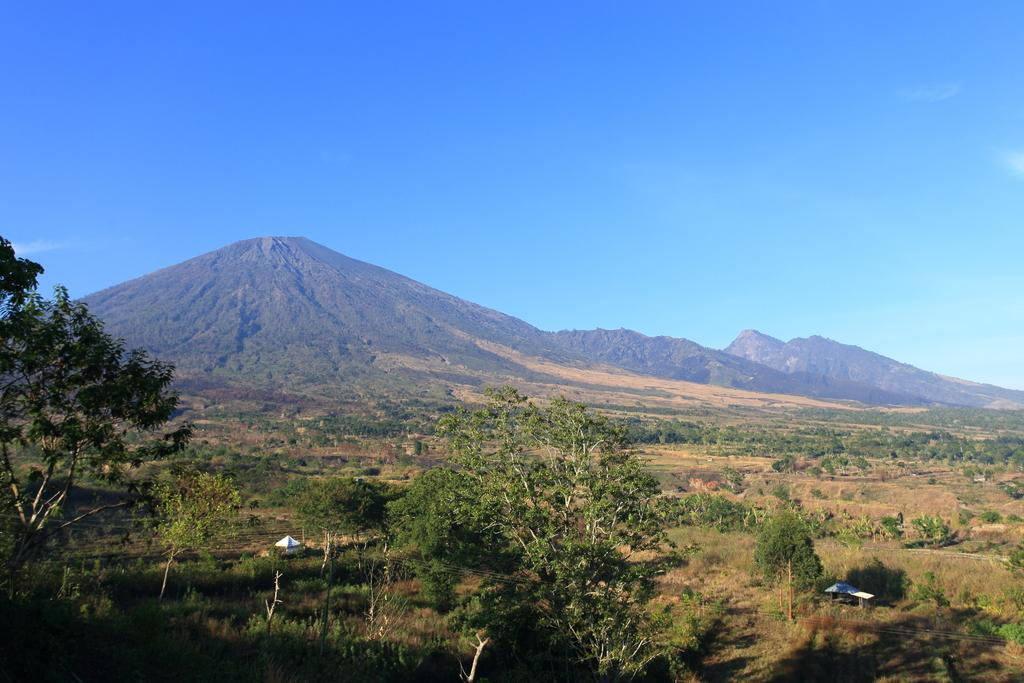Where was the picture taken? The picture was clicked outside the city. What can be seen in the foreground of the image? There are plants and trees, as well as other objects, in the foreground of the image. What is visible in the background of the image? There is a sky and hills visible in the background of the image. What type of credit card is visible in the image? There is no credit card visible in the image. How many hearts can be seen in the image? There are no hearts present in the image. 